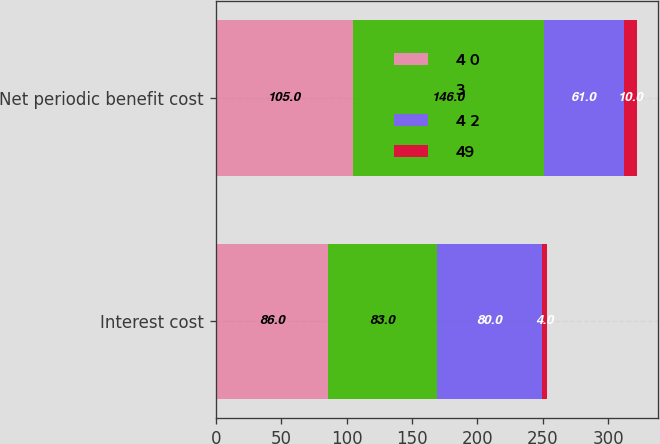Convert chart to OTSL. <chart><loc_0><loc_0><loc_500><loc_500><stacked_bar_chart><ecel><fcel>Interest cost<fcel>Net periodic benefit cost<nl><fcel>4 0<fcel>86<fcel>105<nl><fcel>3<fcel>83<fcel>146<nl><fcel>4 2<fcel>80<fcel>61<nl><fcel>49<fcel>4<fcel>10<nl></chart> 